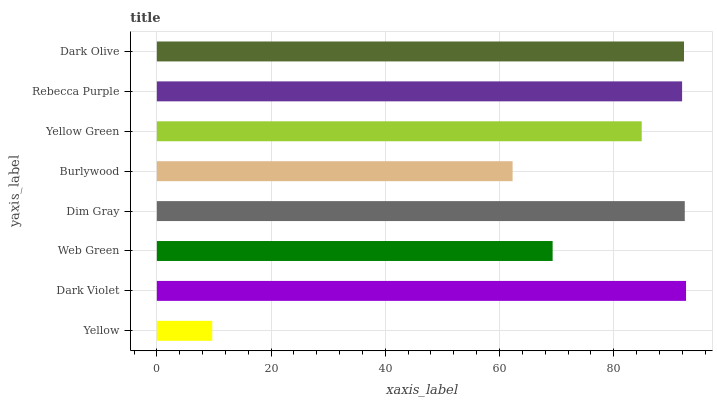Is Yellow the minimum?
Answer yes or no. Yes. Is Dark Violet the maximum?
Answer yes or no. Yes. Is Web Green the minimum?
Answer yes or no. No. Is Web Green the maximum?
Answer yes or no. No. Is Dark Violet greater than Web Green?
Answer yes or no. Yes. Is Web Green less than Dark Violet?
Answer yes or no. Yes. Is Web Green greater than Dark Violet?
Answer yes or no. No. Is Dark Violet less than Web Green?
Answer yes or no. No. Is Rebecca Purple the high median?
Answer yes or no. Yes. Is Yellow Green the low median?
Answer yes or no. Yes. Is Web Green the high median?
Answer yes or no. No. Is Yellow the low median?
Answer yes or no. No. 